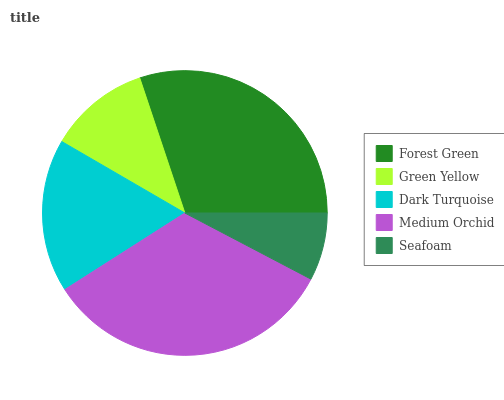Is Seafoam the minimum?
Answer yes or no. Yes. Is Medium Orchid the maximum?
Answer yes or no. Yes. Is Green Yellow the minimum?
Answer yes or no. No. Is Green Yellow the maximum?
Answer yes or no. No. Is Forest Green greater than Green Yellow?
Answer yes or no. Yes. Is Green Yellow less than Forest Green?
Answer yes or no. Yes. Is Green Yellow greater than Forest Green?
Answer yes or no. No. Is Forest Green less than Green Yellow?
Answer yes or no. No. Is Dark Turquoise the high median?
Answer yes or no. Yes. Is Dark Turquoise the low median?
Answer yes or no. Yes. Is Medium Orchid the high median?
Answer yes or no. No. Is Seafoam the low median?
Answer yes or no. No. 